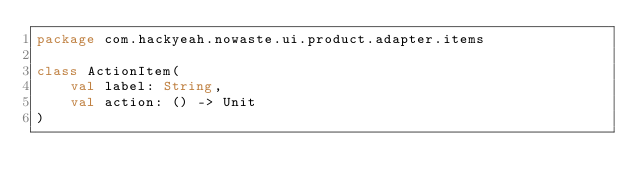Convert code to text. <code><loc_0><loc_0><loc_500><loc_500><_Kotlin_>package com.hackyeah.nowaste.ui.product.adapter.items

class ActionItem(
    val label: String,
    val action: () -> Unit
)</code> 